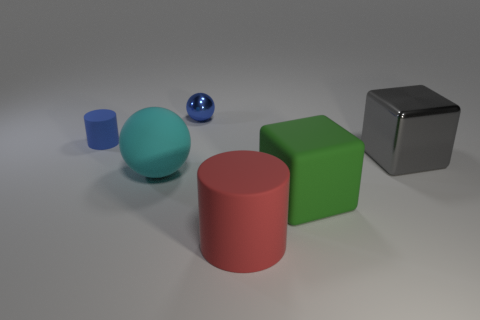What number of other things are there of the same material as the big green thing
Keep it short and to the point. 3. Is the size of the rubber cylinder behind the large cylinder the same as the shiny thing that is to the right of the large rubber cylinder?
Your answer should be very brief. No. What number of things are either large things that are in front of the large cyan matte sphere or cylinders that are behind the green rubber object?
Offer a very short reply. 3. Is there anything else that has the same shape as the tiny metal object?
Keep it short and to the point. Yes. Does the cylinder right of the tiny blue matte cylinder have the same color as the object to the left of the cyan matte object?
Keep it short and to the point. No. What number of metal things are tiny cyan things or red cylinders?
Your response must be concise. 0. Are there any other things that have the same size as the blue matte object?
Your response must be concise. Yes. There is a metallic object that is behind the small thing on the left side of the blue metallic ball; what shape is it?
Provide a succinct answer. Sphere. Do the thing that is in front of the green rubber block and the tiny object that is on the left side of the small blue shiny thing have the same material?
Keep it short and to the point. Yes. There is a small thing that is left of the cyan sphere; what number of big red matte objects are left of it?
Offer a terse response. 0. 